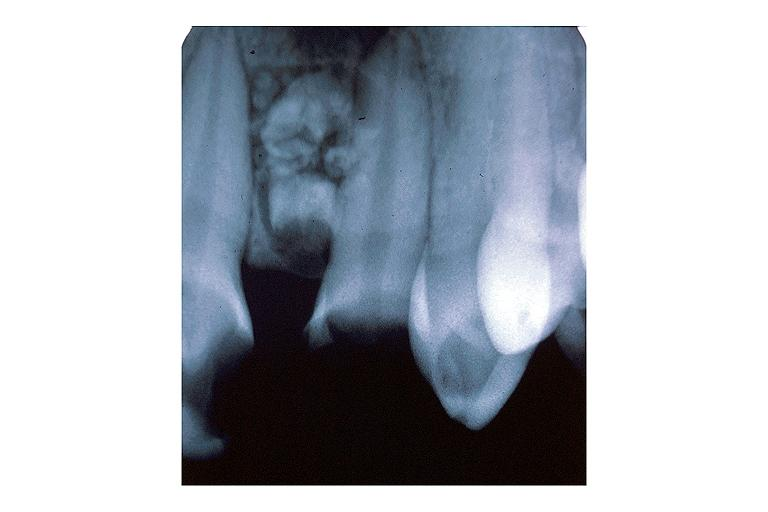does this image show compound odontoma?
Answer the question using a single word or phrase. Yes 